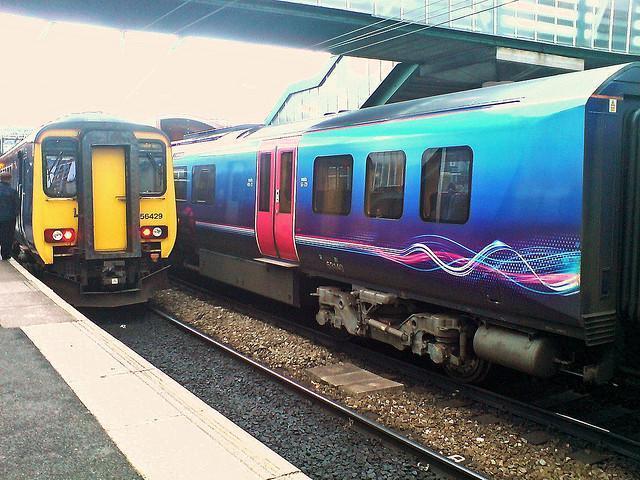How many trains are there?
Give a very brief answer. 2. 